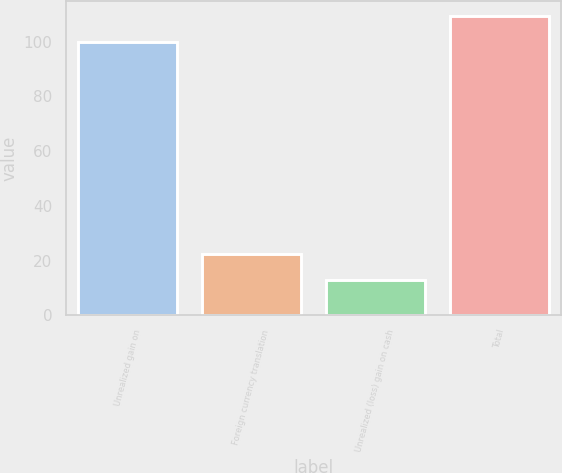Convert chart to OTSL. <chart><loc_0><loc_0><loc_500><loc_500><bar_chart><fcel>Unrealized gain on<fcel>Foreign currency translation<fcel>Unrealized (loss) gain on cash<fcel>Total<nl><fcel>100<fcel>22.3<fcel>13<fcel>109.3<nl></chart> 